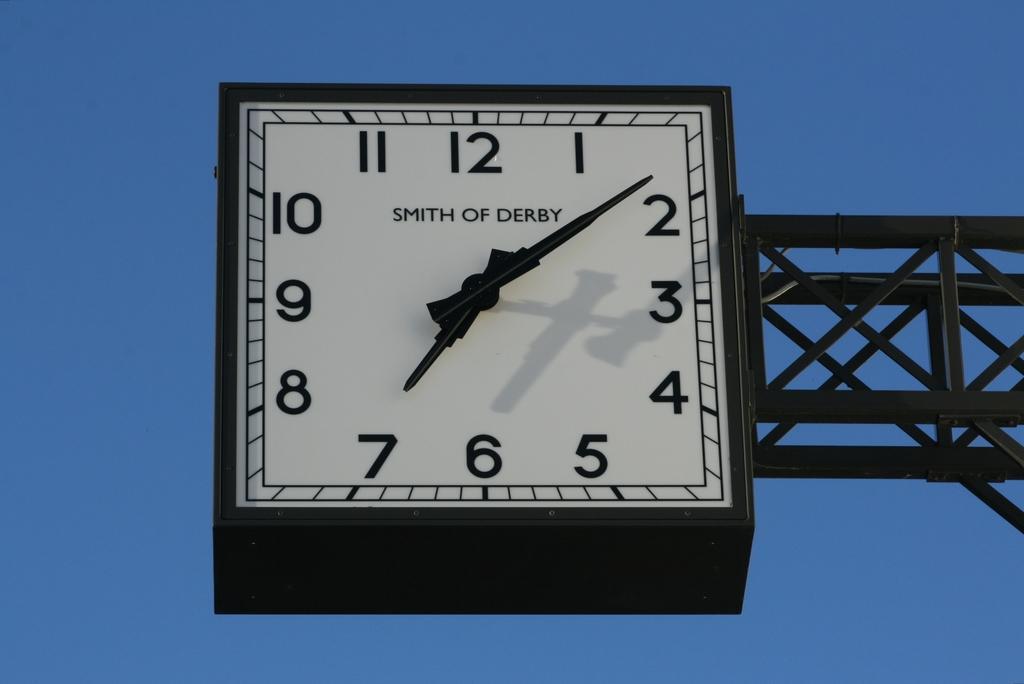What time does the clock say?
Give a very brief answer. 7:09. What words are on the clock?
Your response must be concise. Smith of derby. 